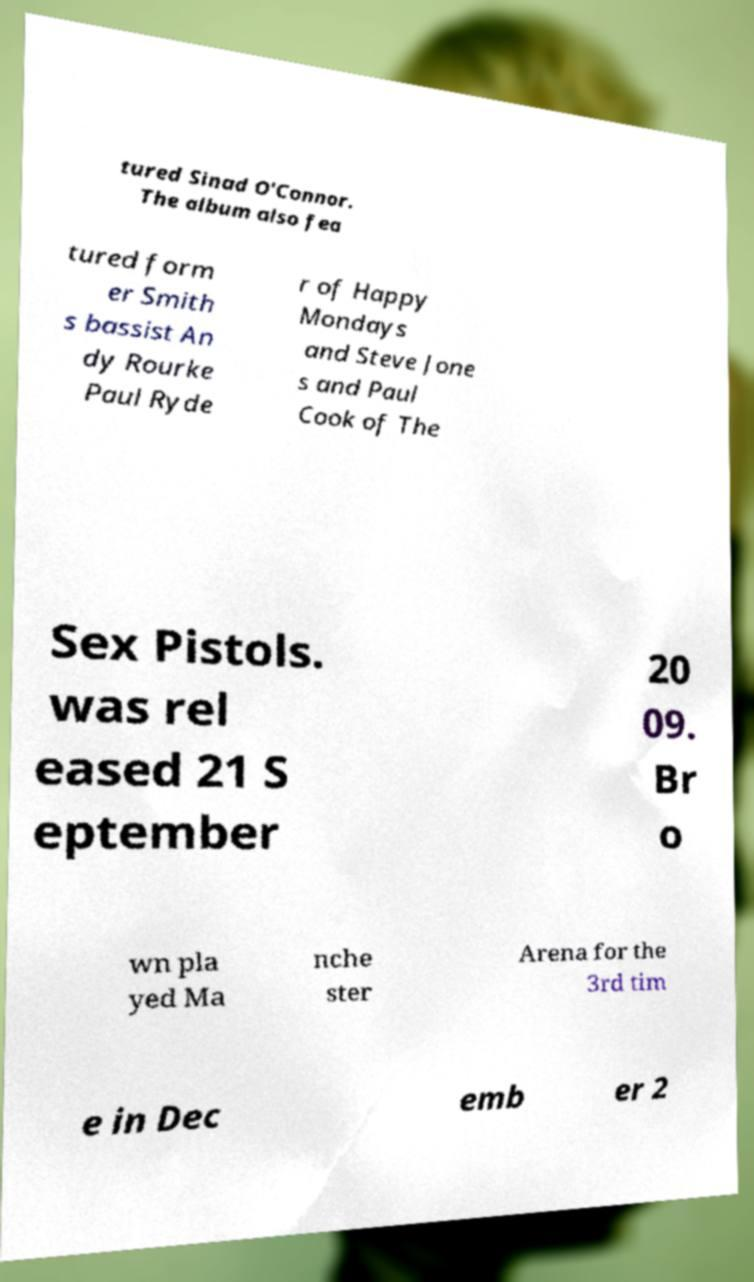I need the written content from this picture converted into text. Can you do that? tured Sinad O'Connor. The album also fea tured form er Smith s bassist An dy Rourke Paul Ryde r of Happy Mondays and Steve Jone s and Paul Cook of The Sex Pistols. was rel eased 21 S eptember 20 09. Br o wn pla yed Ma nche ster Arena for the 3rd tim e in Dec emb er 2 